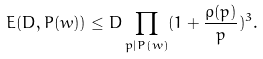<formula> <loc_0><loc_0><loc_500><loc_500>E ( D , P ( w ) ) \leq D \prod _ { p | P ( w ) } ( 1 + \frac { \rho ( p ) } { p } ) ^ { 3 } .</formula> 